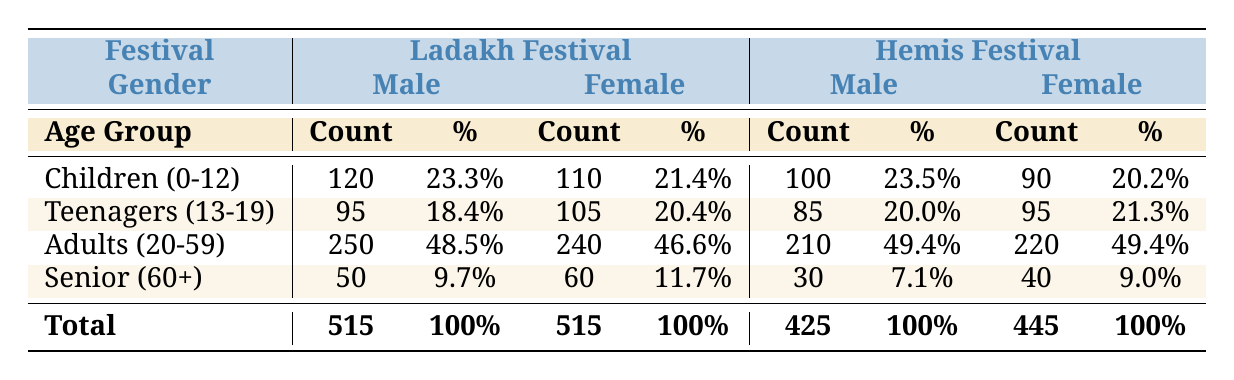What is the total attendance of males at the Ladakh Festival? The total attendance of males is calculated by summing up the attendance counts for males across all age groups for the Ladakh Festival: 120 (Children) + 95 (Teenagers) + 250 (Adults) + 50 (Seniors) = 515.
Answer: 515 What percentage of female attendees at the Hemis Festival are adults (20-59 years old)? The number of female attendees in the Adults category is 220, and the total female attendance at the Hemis Festival is 445. To find the percentage, we use the formula (220 / 445) * 100 = 49.4%.
Answer: 49.4% Is the attendance of Teenagers (13-19) higher among males than females at the Ladakh Festival? From the table, the male attendance in Teenagers is 95, while the female attendance is 105. Since 95 is less than 105, the statement is false.
Answer: No Which age group has the highest male attendance at the Hemis Festival? By reviewing the male attendance counts for the Hemis Festival, we compare: 100 (Children) + 85 (Teenagers) + 210 (Adults) + 30 (Seniors). The highest count among these is 210 for Adults.
Answer: Adults (20-59) What is the difference in attendance between male and female Seniors (60+) at the Hemis Festival? The male attendance for Seniors is 30 and the female attendance is 40. The difference is calculated as 40 - 30 = 10.
Answer: 10 What is the combined total attendance for Children (0-12) at both festivals? The total attendance for Children is the sum of male and female attendees at both festivals: (120 male + 110 female) at the Ladakh Festival and (100 male + 90 female) at the Hemis Festival. This equals (120 + 110) + (100 + 90) = 420.
Answer: 420 Are there more adults (20-59 years old) attending the Ladakh Festival than the Hemis Festival? At the Ladakh Festival, the adult attendance is 250 (male) + 240 (female) = 490. At the Hemis Festival, it is 210 (male) + 220 (female) = 430. Since 490 is greater than 430, the answer is yes.
Answer: Yes What is the average number of attendees in the Senior (60+) category across both festivals? The total attendance in the Senior category is 50 (male) + 60 (female) from the Ladakh Festival and 30 (male) + 40 (female) from the Hemis Festival, which sums to 50 + 60 + 30 + 40 = 180. Since there are 4 data points (two festivals and two genders), the average is 180 / 4 = 45.
Answer: 45 